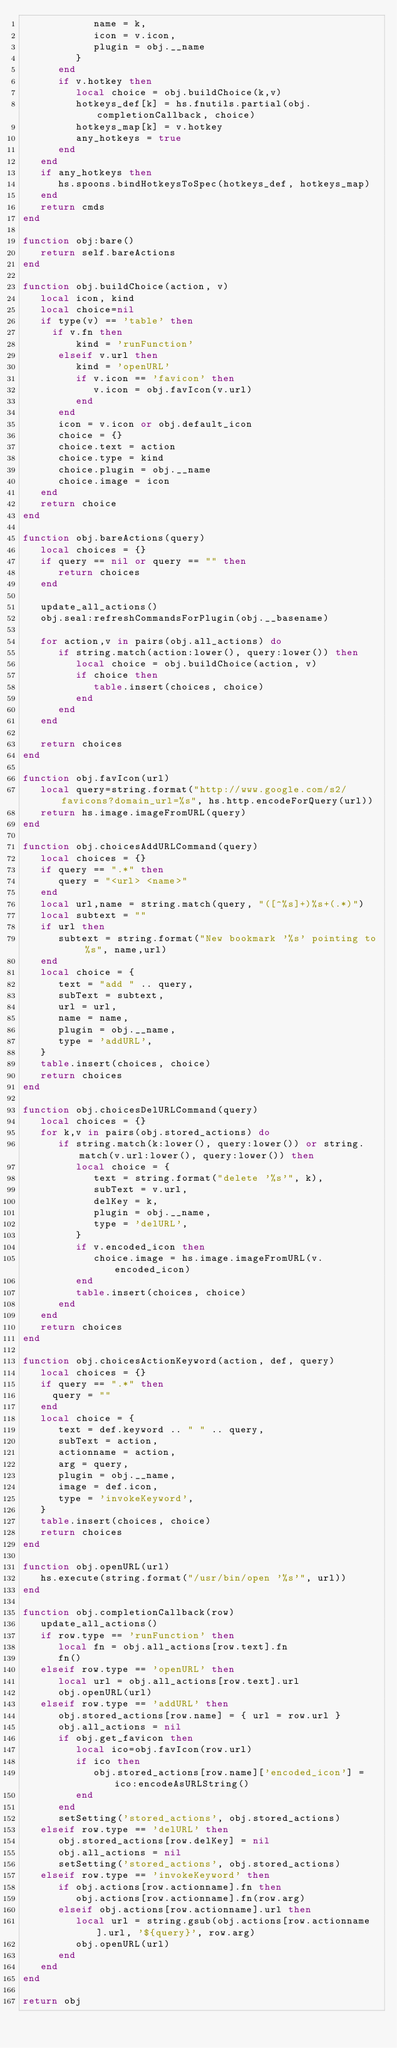Convert code to text. <code><loc_0><loc_0><loc_500><loc_500><_Lua_>            name = k,
            icon = v.icon,
            plugin = obj.__name
         }
      end
      if v.hotkey then
         local choice = obj.buildChoice(k,v)
         hotkeys_def[k] = hs.fnutils.partial(obj.completionCallback, choice)
         hotkeys_map[k] = v.hotkey
         any_hotkeys = true
      end
   end
   if any_hotkeys then
      hs.spoons.bindHotkeysToSpec(hotkeys_def, hotkeys_map)
   end
   return cmds
end

function obj:bare()
   return self.bareActions
end

function obj.buildChoice(action, v)
   local icon, kind
   local choice=nil
   if type(v) == 'table' then
     if v.fn then
         kind = 'runFunction'
      elseif v.url then
         kind = 'openURL'
         if v.icon == 'favicon' then
            v.icon = obj.favIcon(v.url)
         end
      end
      icon = v.icon or obj.default_icon
      choice = {}
      choice.text = action
      choice.type = kind
      choice.plugin = obj.__name
      choice.image = icon
   end
   return choice
end

function obj.bareActions(query)
   local choices = {}
   if query == nil or query == "" then
      return choices
   end

   update_all_actions()
   obj.seal:refreshCommandsForPlugin(obj.__basename)

   for action,v in pairs(obj.all_actions) do
      if string.match(action:lower(), query:lower()) then
         local choice = obj.buildChoice(action, v)
         if choice then
            table.insert(choices, choice)
         end
      end
   end

   return choices
end

function obj.favIcon(url)
   local query=string.format("http://www.google.com/s2/favicons?domain_url=%s", hs.http.encodeForQuery(url))
   return hs.image.imageFromURL(query)
end

function obj.choicesAddURLCommand(query)
   local choices = {}
   if query == ".*" then
      query = "<url> <name>"
   end
   local url,name = string.match(query, "([^%s]+)%s+(.*)")
   local subtext = ""
   if url then
      subtext = string.format("New bookmark '%s' pointing to %s", name,url)
   end
   local choice = {
      text = "add " .. query,
      subText = subtext,
      url = url,
      name = name,
      plugin = obj.__name,
      type = 'addURL',
   }
   table.insert(choices, choice)
   return choices
end

function obj.choicesDelURLCommand(query)
   local choices = {}
   for k,v in pairs(obj.stored_actions) do
      if string.match(k:lower(), query:lower()) or string.match(v.url:lower(), query:lower()) then
         local choice = {
            text = string.format("delete '%s'", k),
            subText = v.url,
            delKey = k,
            plugin = obj.__name,
            type = 'delURL',
         }
         if v.encoded_icon then
            choice.image = hs.image.imageFromURL(v.encoded_icon)
         end
         table.insert(choices, choice)
      end
   end
   return choices
end

function obj.choicesActionKeyword(action, def, query)
   local choices = {}
   if query == ".*" then
     query = ""
   end
   local choice = {
      text = def.keyword .. " " .. query,
      subText = action,
      actionname = action,
      arg = query,
      plugin = obj.__name,
      image = def.icon,
      type = 'invokeKeyword',
   }
   table.insert(choices, choice)
   return choices
end

function obj.openURL(url)
   hs.execute(string.format("/usr/bin/open '%s'", url))
end

function obj.completionCallback(row)
   update_all_actions()
   if row.type == 'runFunction' then
      local fn = obj.all_actions[row.text].fn
      fn()
   elseif row.type == 'openURL' then
      local url = obj.all_actions[row.text].url
      obj.openURL(url)
   elseif row.type == 'addURL' then
      obj.stored_actions[row.name] = { url = row.url }
      obj.all_actions = nil
      if obj.get_favicon then
         local ico=obj.favIcon(row.url)
         if ico then
            obj.stored_actions[row.name]['encoded_icon'] = ico:encodeAsURLString()
         end
      end
      setSetting('stored_actions', obj.stored_actions)
   elseif row.type == 'delURL' then
      obj.stored_actions[row.delKey] = nil
      obj.all_actions = nil
      setSetting('stored_actions', obj.stored_actions)
   elseif row.type == 'invokeKeyword' then
      if obj.actions[row.actionname].fn then
         obj.actions[row.actionname].fn(row.arg)
      elseif obj.actions[row.actionname].url then
         local url = string.gsub(obj.actions[row.actionname].url, '${query}', row.arg)
         obj.openURL(url)
      end
   end
end

return obj
</code> 